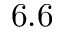Convert formula to latex. <formula><loc_0><loc_0><loc_500><loc_500>6 . 6</formula> 